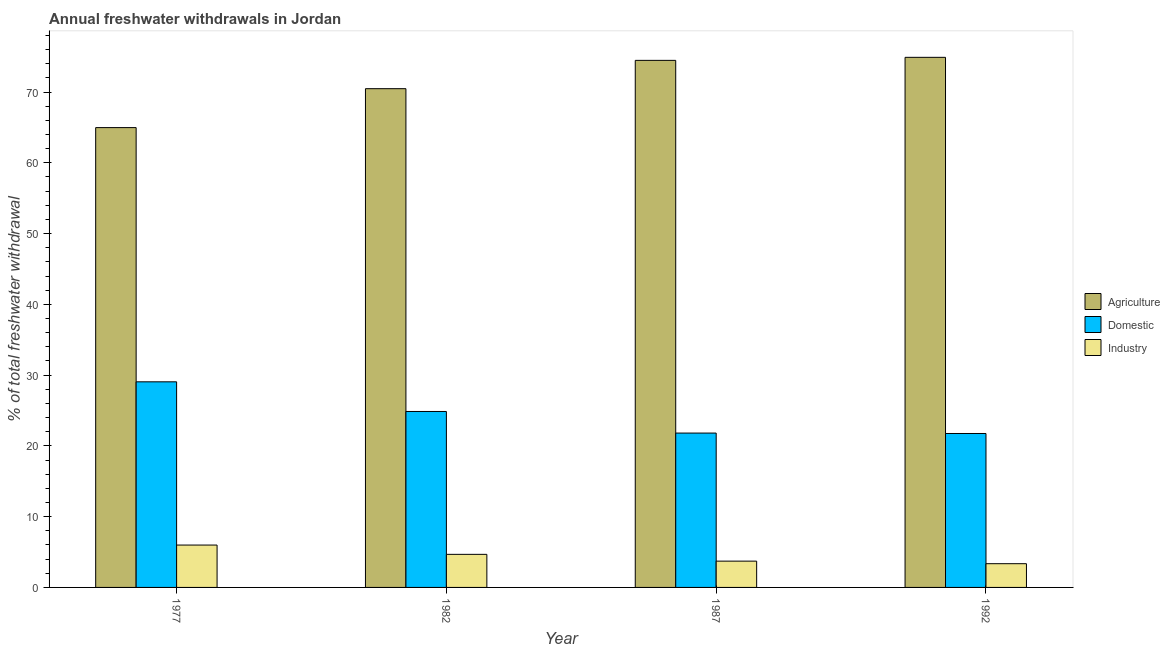How many groups of bars are there?
Provide a succinct answer. 4. Are the number of bars per tick equal to the number of legend labels?
Make the answer very short. Yes. How many bars are there on the 2nd tick from the left?
Give a very brief answer. 3. How many bars are there on the 3rd tick from the right?
Make the answer very short. 3. In how many cases, is the number of bars for a given year not equal to the number of legend labels?
Provide a short and direct response. 0. What is the percentage of freshwater withdrawal for agriculture in 1992?
Offer a terse response. 74.9. Across all years, what is the maximum percentage of freshwater withdrawal for domestic purposes?
Make the answer very short. 29.05. Across all years, what is the minimum percentage of freshwater withdrawal for industry?
Your answer should be compact. 3.35. What is the total percentage of freshwater withdrawal for domestic purposes in the graph?
Provide a short and direct response. 97.47. What is the difference between the percentage of freshwater withdrawal for domestic purposes in 1982 and the percentage of freshwater withdrawal for industry in 1987?
Your response must be concise. 3.05. What is the average percentage of freshwater withdrawal for agriculture per year?
Offer a terse response. 71.2. In the year 1982, what is the difference between the percentage of freshwater withdrawal for agriculture and percentage of freshwater withdrawal for industry?
Give a very brief answer. 0. What is the ratio of the percentage of freshwater withdrawal for agriculture in 1982 to that in 1987?
Make the answer very short. 0.95. Is the percentage of freshwater withdrawal for domestic purposes in 1977 less than that in 1987?
Ensure brevity in your answer.  No. Is the difference between the percentage of freshwater withdrawal for agriculture in 1982 and 1987 greater than the difference between the percentage of freshwater withdrawal for domestic purposes in 1982 and 1987?
Your answer should be very brief. No. What is the difference between the highest and the second highest percentage of freshwater withdrawal for industry?
Your response must be concise. 1.31. What is the difference between the highest and the lowest percentage of freshwater withdrawal for industry?
Make the answer very short. 2.63. What does the 3rd bar from the left in 1977 represents?
Your answer should be compact. Industry. What does the 3rd bar from the right in 1992 represents?
Ensure brevity in your answer.  Agriculture. Are all the bars in the graph horizontal?
Keep it short and to the point. No. Are the values on the major ticks of Y-axis written in scientific E-notation?
Keep it short and to the point. No. Where does the legend appear in the graph?
Your response must be concise. Center right. How many legend labels are there?
Make the answer very short. 3. What is the title of the graph?
Make the answer very short. Annual freshwater withdrawals in Jordan. What is the label or title of the Y-axis?
Your answer should be compact. % of total freshwater withdrawal. What is the % of total freshwater withdrawal of Agriculture in 1977?
Provide a succinct answer. 64.97. What is the % of total freshwater withdrawal in Domestic in 1977?
Offer a terse response. 29.05. What is the % of total freshwater withdrawal of Industry in 1977?
Your response must be concise. 5.99. What is the % of total freshwater withdrawal in Agriculture in 1982?
Make the answer very short. 70.47. What is the % of total freshwater withdrawal in Domestic in 1982?
Make the answer very short. 24.86. What is the % of total freshwater withdrawal in Industry in 1982?
Provide a short and direct response. 4.67. What is the % of total freshwater withdrawal of Agriculture in 1987?
Offer a very short reply. 74.47. What is the % of total freshwater withdrawal of Domestic in 1987?
Provide a succinct answer. 21.81. What is the % of total freshwater withdrawal in Industry in 1987?
Provide a short and direct response. 3.72. What is the % of total freshwater withdrawal of Agriculture in 1992?
Your answer should be very brief. 74.9. What is the % of total freshwater withdrawal in Domestic in 1992?
Provide a succinct answer. 21.75. What is the % of total freshwater withdrawal of Industry in 1992?
Give a very brief answer. 3.35. Across all years, what is the maximum % of total freshwater withdrawal in Agriculture?
Offer a very short reply. 74.9. Across all years, what is the maximum % of total freshwater withdrawal of Domestic?
Your response must be concise. 29.05. Across all years, what is the maximum % of total freshwater withdrawal in Industry?
Your answer should be very brief. 5.99. Across all years, what is the minimum % of total freshwater withdrawal in Agriculture?
Provide a succinct answer. 64.97. Across all years, what is the minimum % of total freshwater withdrawal in Domestic?
Offer a very short reply. 21.75. Across all years, what is the minimum % of total freshwater withdrawal of Industry?
Offer a terse response. 3.35. What is the total % of total freshwater withdrawal in Agriculture in the graph?
Keep it short and to the point. 284.81. What is the total % of total freshwater withdrawal in Domestic in the graph?
Your answer should be compact. 97.47. What is the total % of total freshwater withdrawal in Industry in the graph?
Keep it short and to the point. 17.73. What is the difference between the % of total freshwater withdrawal in Domestic in 1977 and that in 1982?
Offer a terse response. 4.19. What is the difference between the % of total freshwater withdrawal in Industry in 1977 and that in 1982?
Your answer should be compact. 1.31. What is the difference between the % of total freshwater withdrawal of Agriculture in 1977 and that in 1987?
Keep it short and to the point. -9.5. What is the difference between the % of total freshwater withdrawal of Domestic in 1977 and that in 1987?
Make the answer very short. 7.24. What is the difference between the % of total freshwater withdrawal of Industry in 1977 and that in 1987?
Provide a succinct answer. 2.27. What is the difference between the % of total freshwater withdrawal of Agriculture in 1977 and that in 1992?
Offer a very short reply. -9.93. What is the difference between the % of total freshwater withdrawal of Industry in 1977 and that in 1992?
Make the answer very short. 2.63. What is the difference between the % of total freshwater withdrawal in Agriculture in 1982 and that in 1987?
Your answer should be compact. -4. What is the difference between the % of total freshwater withdrawal of Domestic in 1982 and that in 1987?
Keep it short and to the point. 3.05. What is the difference between the % of total freshwater withdrawal of Agriculture in 1982 and that in 1992?
Offer a terse response. -4.43. What is the difference between the % of total freshwater withdrawal in Domestic in 1982 and that in 1992?
Offer a very short reply. 3.11. What is the difference between the % of total freshwater withdrawal of Industry in 1982 and that in 1992?
Offer a very short reply. 1.32. What is the difference between the % of total freshwater withdrawal in Agriculture in 1987 and that in 1992?
Offer a very short reply. -0.43. What is the difference between the % of total freshwater withdrawal in Domestic in 1987 and that in 1992?
Provide a short and direct response. 0.06. What is the difference between the % of total freshwater withdrawal of Industry in 1987 and that in 1992?
Ensure brevity in your answer.  0.36. What is the difference between the % of total freshwater withdrawal in Agriculture in 1977 and the % of total freshwater withdrawal in Domestic in 1982?
Provide a succinct answer. 40.11. What is the difference between the % of total freshwater withdrawal of Agriculture in 1977 and the % of total freshwater withdrawal of Industry in 1982?
Keep it short and to the point. 60.3. What is the difference between the % of total freshwater withdrawal in Domestic in 1977 and the % of total freshwater withdrawal in Industry in 1982?
Provide a succinct answer. 24.38. What is the difference between the % of total freshwater withdrawal of Agriculture in 1977 and the % of total freshwater withdrawal of Domestic in 1987?
Ensure brevity in your answer.  43.16. What is the difference between the % of total freshwater withdrawal in Agriculture in 1977 and the % of total freshwater withdrawal in Industry in 1987?
Make the answer very short. 61.25. What is the difference between the % of total freshwater withdrawal in Domestic in 1977 and the % of total freshwater withdrawal in Industry in 1987?
Offer a terse response. 25.33. What is the difference between the % of total freshwater withdrawal in Agriculture in 1977 and the % of total freshwater withdrawal in Domestic in 1992?
Your answer should be compact. 43.22. What is the difference between the % of total freshwater withdrawal of Agriculture in 1977 and the % of total freshwater withdrawal of Industry in 1992?
Your answer should be compact. 61.62. What is the difference between the % of total freshwater withdrawal of Domestic in 1977 and the % of total freshwater withdrawal of Industry in 1992?
Give a very brief answer. 25.7. What is the difference between the % of total freshwater withdrawal in Agriculture in 1982 and the % of total freshwater withdrawal in Domestic in 1987?
Your answer should be very brief. 48.66. What is the difference between the % of total freshwater withdrawal of Agriculture in 1982 and the % of total freshwater withdrawal of Industry in 1987?
Provide a short and direct response. 66.75. What is the difference between the % of total freshwater withdrawal of Domestic in 1982 and the % of total freshwater withdrawal of Industry in 1987?
Offer a terse response. 21.14. What is the difference between the % of total freshwater withdrawal in Agriculture in 1982 and the % of total freshwater withdrawal in Domestic in 1992?
Ensure brevity in your answer.  48.72. What is the difference between the % of total freshwater withdrawal of Agriculture in 1982 and the % of total freshwater withdrawal of Industry in 1992?
Your answer should be very brief. 67.12. What is the difference between the % of total freshwater withdrawal of Domestic in 1982 and the % of total freshwater withdrawal of Industry in 1992?
Your answer should be compact. 21.51. What is the difference between the % of total freshwater withdrawal in Agriculture in 1987 and the % of total freshwater withdrawal in Domestic in 1992?
Give a very brief answer. 52.72. What is the difference between the % of total freshwater withdrawal of Agriculture in 1987 and the % of total freshwater withdrawal of Industry in 1992?
Your response must be concise. 71.12. What is the difference between the % of total freshwater withdrawal of Domestic in 1987 and the % of total freshwater withdrawal of Industry in 1992?
Provide a short and direct response. 18.46. What is the average % of total freshwater withdrawal of Agriculture per year?
Offer a very short reply. 71.2. What is the average % of total freshwater withdrawal in Domestic per year?
Ensure brevity in your answer.  24.37. What is the average % of total freshwater withdrawal in Industry per year?
Your answer should be compact. 4.43. In the year 1977, what is the difference between the % of total freshwater withdrawal of Agriculture and % of total freshwater withdrawal of Domestic?
Offer a very short reply. 35.92. In the year 1977, what is the difference between the % of total freshwater withdrawal in Agriculture and % of total freshwater withdrawal in Industry?
Provide a short and direct response. 58.98. In the year 1977, what is the difference between the % of total freshwater withdrawal in Domestic and % of total freshwater withdrawal in Industry?
Give a very brief answer. 23.06. In the year 1982, what is the difference between the % of total freshwater withdrawal in Agriculture and % of total freshwater withdrawal in Domestic?
Keep it short and to the point. 45.61. In the year 1982, what is the difference between the % of total freshwater withdrawal in Agriculture and % of total freshwater withdrawal in Industry?
Keep it short and to the point. 65.8. In the year 1982, what is the difference between the % of total freshwater withdrawal of Domestic and % of total freshwater withdrawal of Industry?
Ensure brevity in your answer.  20.19. In the year 1987, what is the difference between the % of total freshwater withdrawal in Agriculture and % of total freshwater withdrawal in Domestic?
Your response must be concise. 52.66. In the year 1987, what is the difference between the % of total freshwater withdrawal of Agriculture and % of total freshwater withdrawal of Industry?
Provide a short and direct response. 70.75. In the year 1987, what is the difference between the % of total freshwater withdrawal of Domestic and % of total freshwater withdrawal of Industry?
Your answer should be compact. 18.09. In the year 1992, what is the difference between the % of total freshwater withdrawal of Agriculture and % of total freshwater withdrawal of Domestic?
Give a very brief answer. 53.15. In the year 1992, what is the difference between the % of total freshwater withdrawal of Agriculture and % of total freshwater withdrawal of Industry?
Make the answer very short. 71.55. In the year 1992, what is the difference between the % of total freshwater withdrawal of Domestic and % of total freshwater withdrawal of Industry?
Give a very brief answer. 18.4. What is the ratio of the % of total freshwater withdrawal of Agriculture in 1977 to that in 1982?
Your answer should be compact. 0.92. What is the ratio of the % of total freshwater withdrawal in Domestic in 1977 to that in 1982?
Make the answer very short. 1.17. What is the ratio of the % of total freshwater withdrawal in Industry in 1977 to that in 1982?
Make the answer very short. 1.28. What is the ratio of the % of total freshwater withdrawal of Agriculture in 1977 to that in 1987?
Ensure brevity in your answer.  0.87. What is the ratio of the % of total freshwater withdrawal of Domestic in 1977 to that in 1987?
Make the answer very short. 1.33. What is the ratio of the % of total freshwater withdrawal in Industry in 1977 to that in 1987?
Your response must be concise. 1.61. What is the ratio of the % of total freshwater withdrawal in Agriculture in 1977 to that in 1992?
Make the answer very short. 0.87. What is the ratio of the % of total freshwater withdrawal in Domestic in 1977 to that in 1992?
Your answer should be very brief. 1.34. What is the ratio of the % of total freshwater withdrawal in Industry in 1977 to that in 1992?
Make the answer very short. 1.78. What is the ratio of the % of total freshwater withdrawal of Agriculture in 1982 to that in 1987?
Keep it short and to the point. 0.95. What is the ratio of the % of total freshwater withdrawal in Domestic in 1982 to that in 1987?
Make the answer very short. 1.14. What is the ratio of the % of total freshwater withdrawal of Industry in 1982 to that in 1987?
Offer a very short reply. 1.26. What is the ratio of the % of total freshwater withdrawal of Agriculture in 1982 to that in 1992?
Offer a terse response. 0.94. What is the ratio of the % of total freshwater withdrawal in Domestic in 1982 to that in 1992?
Give a very brief answer. 1.14. What is the ratio of the % of total freshwater withdrawal of Industry in 1982 to that in 1992?
Give a very brief answer. 1.39. What is the ratio of the % of total freshwater withdrawal in Agriculture in 1987 to that in 1992?
Your answer should be compact. 0.99. What is the ratio of the % of total freshwater withdrawal of Industry in 1987 to that in 1992?
Your response must be concise. 1.11. What is the difference between the highest and the second highest % of total freshwater withdrawal in Agriculture?
Your response must be concise. 0.43. What is the difference between the highest and the second highest % of total freshwater withdrawal of Domestic?
Offer a terse response. 4.19. What is the difference between the highest and the second highest % of total freshwater withdrawal of Industry?
Give a very brief answer. 1.31. What is the difference between the highest and the lowest % of total freshwater withdrawal of Agriculture?
Ensure brevity in your answer.  9.93. What is the difference between the highest and the lowest % of total freshwater withdrawal of Domestic?
Give a very brief answer. 7.3. What is the difference between the highest and the lowest % of total freshwater withdrawal in Industry?
Your answer should be very brief. 2.63. 